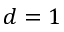Convert formula to latex. <formula><loc_0><loc_0><loc_500><loc_500>d = 1</formula> 